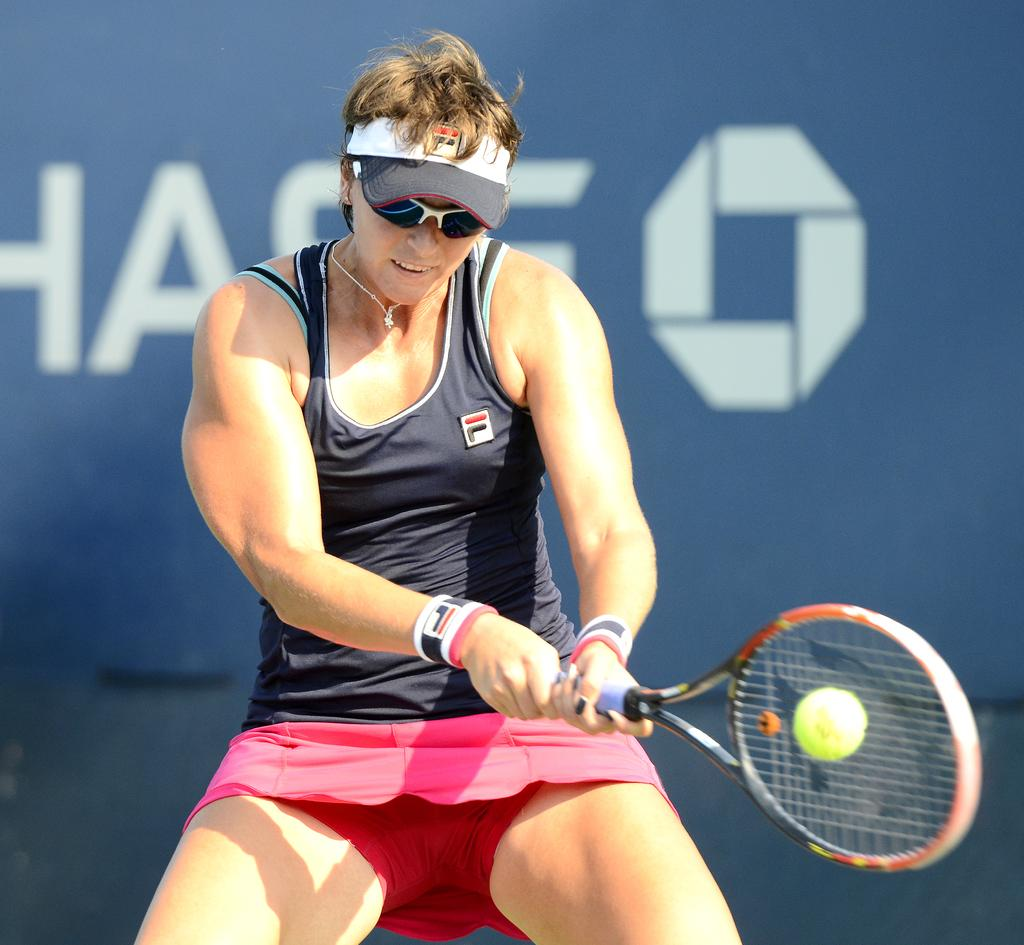Who is the main subject in the image? There is a woman in the image. What is the woman doing in the image? The woman is standing and playing with a racket. What is the woman holding in her hands? The woman is holding a racket in her hands. What type of umbrella is the woman using to play with the racket in the image? There is no umbrella present in the image, and the woman is not using any umbrella to play with the racket. 